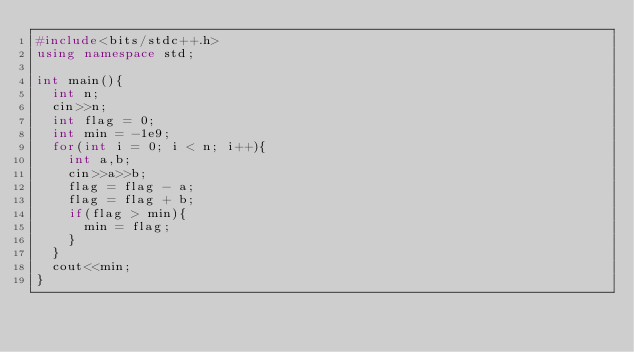Convert code to text. <code><loc_0><loc_0><loc_500><loc_500><_C++_>#include<bits/stdc++.h>
using namespace std;

int main(){
	int n;
	cin>>n;
	int flag = 0;
	int min = -1e9;
	for(int i = 0; i < n; i++){
		int a,b;
		cin>>a>>b;
		flag = flag - a;
		flag = flag + b;
		if(flag > min){
			min = flag;
		}
	}
	cout<<min;
}</code> 